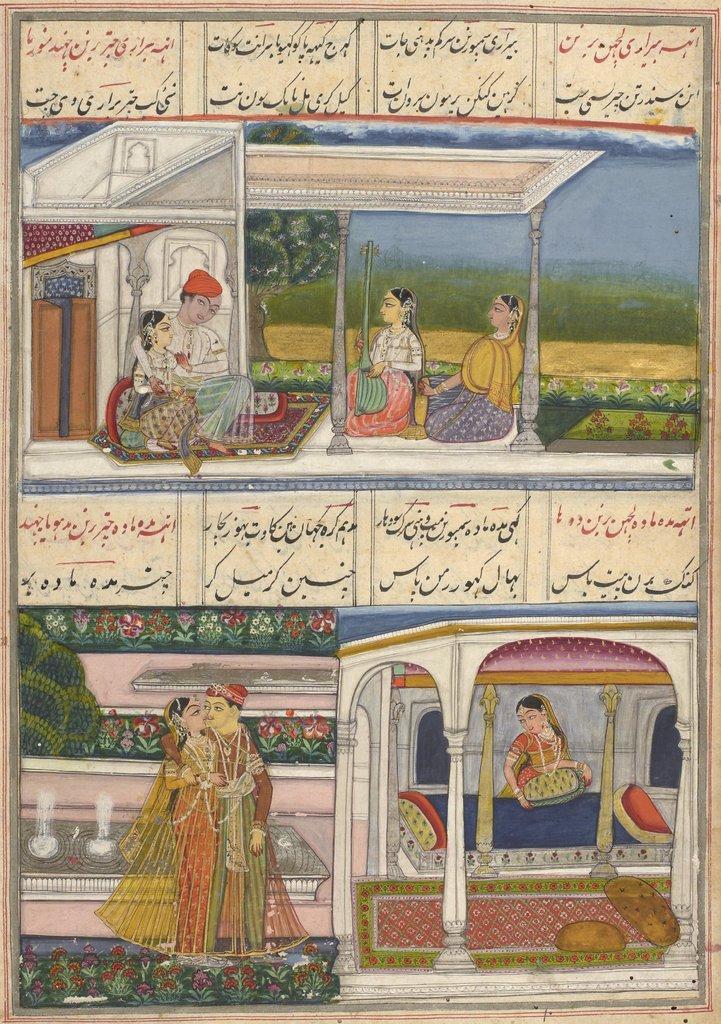How would you summarize this image in a sentence or two? This is a collage image. In this image I can see the painting. In the painting I can see few people with different color dresses and one person is holding the musical instrument. These people are sitting in the house. I can also see the flowers in the image. At the back of few people I can see the trees and the water. I can also see the text in the image. 